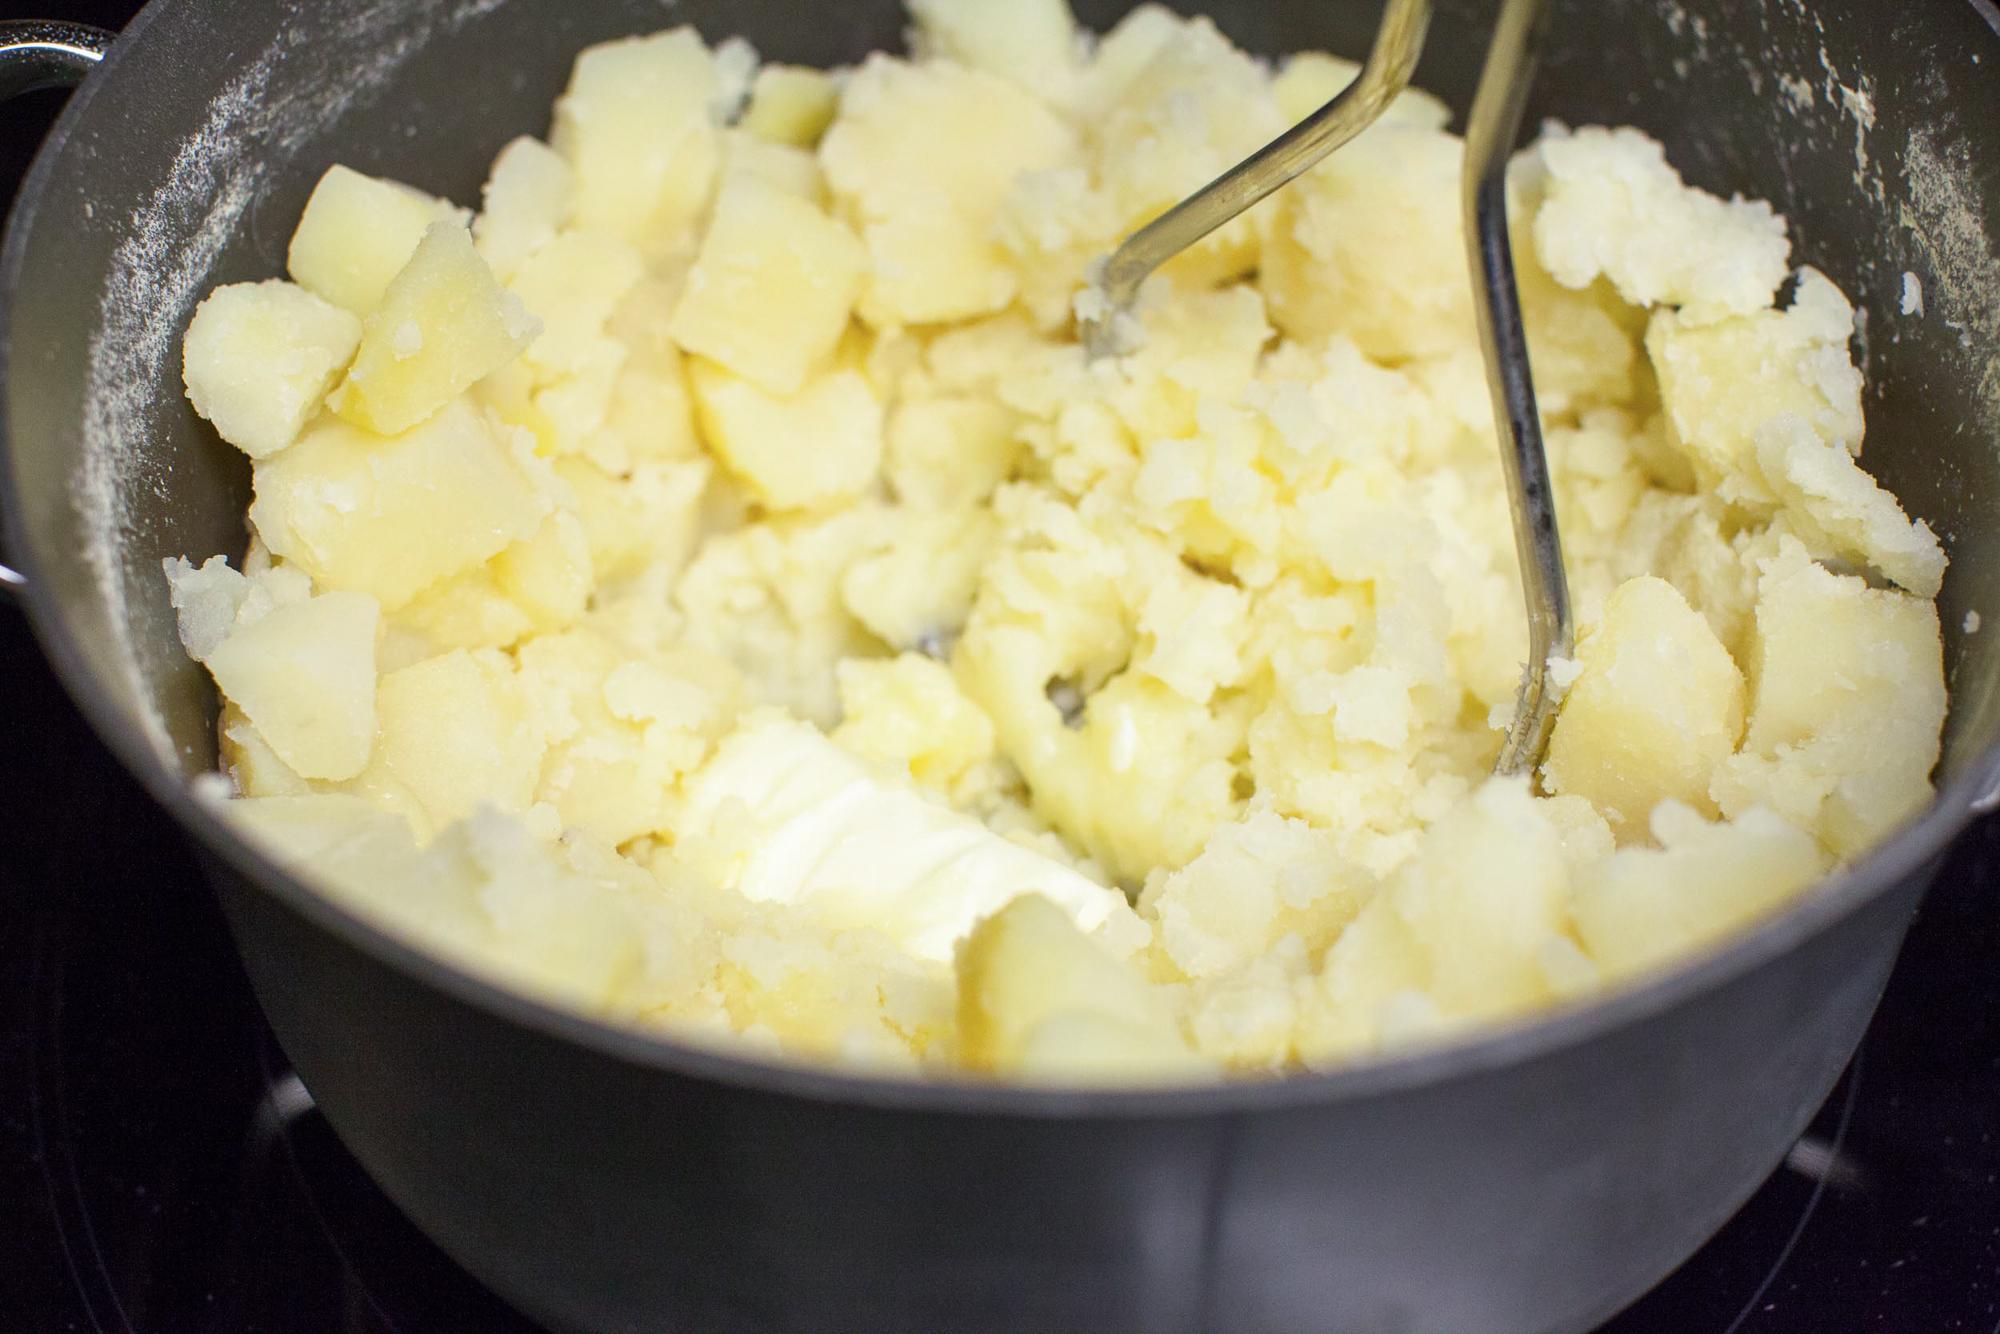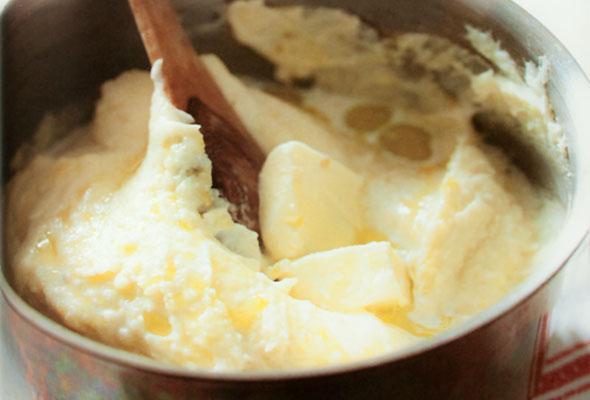The first image is the image on the left, the second image is the image on the right. Assess this claim about the two images: "A metal kitchen utinsil is sitting in a bowl of potatoes.". Correct or not? Answer yes or no. Yes. The first image is the image on the left, the second image is the image on the right. Examine the images to the left and right. Is the description "An image shows a bowl of potatoes with a metal potato masher sticking out." accurate? Answer yes or no. Yes. 